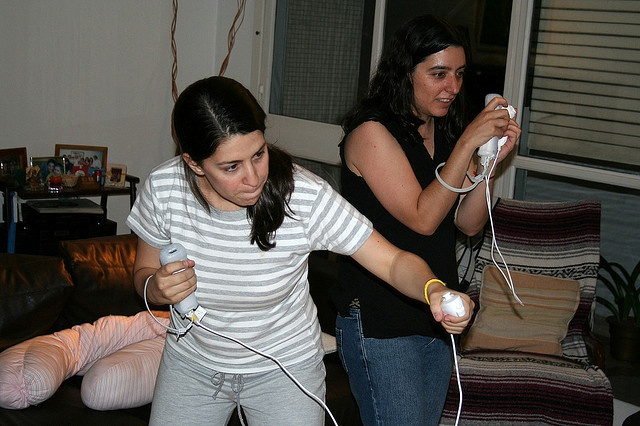Describe the objects in this image and their specific colors. I can see people in gray, darkgray, lightgray, and black tones, people in gray, black, brown, and darkblue tones, chair in gray, black, and maroon tones, couch in gray, black, maroon, and brown tones, and remote in gray, darkgray, and lightgray tones in this image. 